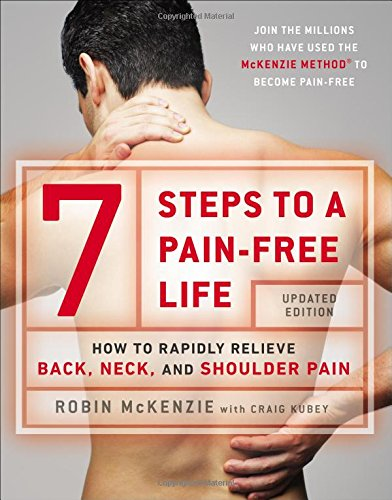What is the title of this book? The title of the book shown in the image is '7 Steps to a Pain-Free Life: How to Rapidly Relieve Back, Neck, and Shoulder Pain', which highlights its focus on alleviating physical pain through self-help techniques. 